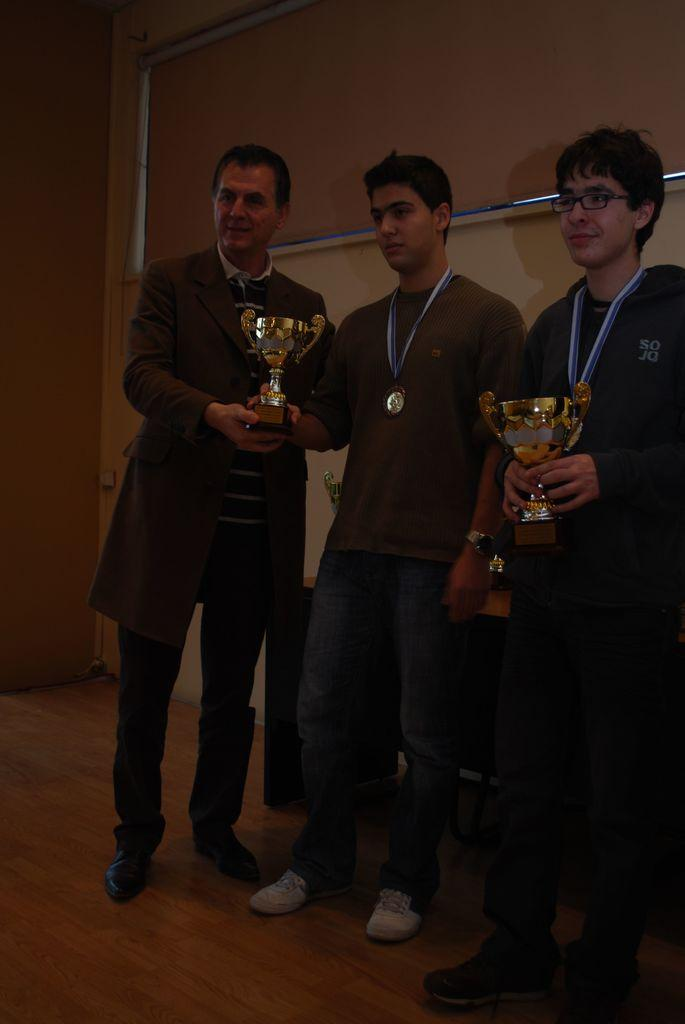How many people are in the image? There are three men standing in the image. What are the men holding in the image? The men are holding two trophies. What can be seen in the background of the image? There is a wall in the background of the image. What are the men wearing that indicates they have achieved something? Two of the men are wearing medals. What is visible at the bottom of the image? There is a floor visible at the bottom of the image. How many dolls are sitting on the floor in the image? There are no dolls present in the image; it features three men holding trophies and wearing medals. What part of the trophy is adjustable in the image? There is no indication that any part of the trophies is adjustable in the image. 